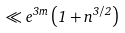Convert formula to latex. <formula><loc_0><loc_0><loc_500><loc_500>\ll e ^ { 3 m } \left ( 1 + n ^ { 3 / 2 } \right )</formula> 